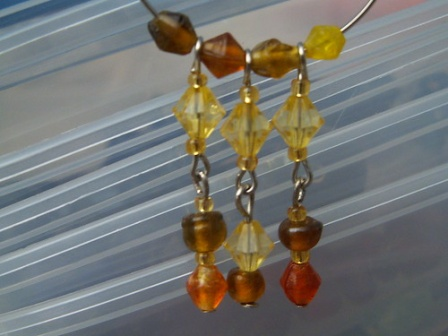In a modern fashion shoot, how would these earrings be styled on a model? In a contemporary fashion shoot, these earrings could be styled on a model wearing a minimalist outfit, ensuring that the focus remains on the accessories. The model might don a sleek, solid-colored dress, perhaps in a neutral tone such as black, white, or beige, to juxtapose against the vibrant hues of the earrings. Her hair could be styled in an elegant updo or slicked back, drawing attention to her ears and the intricate design of the earrings. The makeup would be subtle yet luminous, with a hint of gold highlighter to complement the yellow beads. The shoot might take place in a similarly minimalistic setting with soft lighting and a simple backdrop, allowing the earrings to truly shine as the statement piece of the ensemble. 